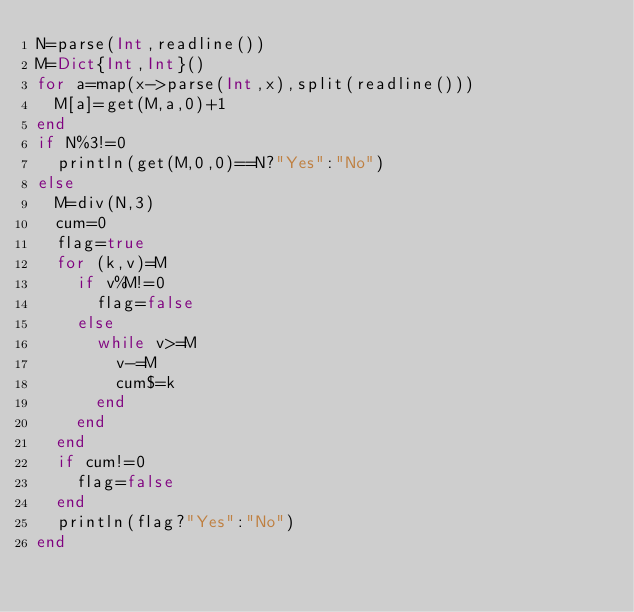Convert code to text. <code><loc_0><loc_0><loc_500><loc_500><_Julia_>N=parse(Int,readline())
M=Dict{Int,Int}()
for a=map(x->parse(Int,x),split(readline()))
	M[a]=get(M,a,0)+1
end
if N%3!=0
	println(get(M,0,0)==N?"Yes":"No")
else
	M=div(N,3)
	cum=0
	flag=true
	for (k,v)=M
		if v%M!=0
			flag=false
		else
			while v>=M
				v-=M
				cum$=k
			end
		end
	end
	if cum!=0
		flag=false
	end
	println(flag?"Yes":"No")
end
</code> 